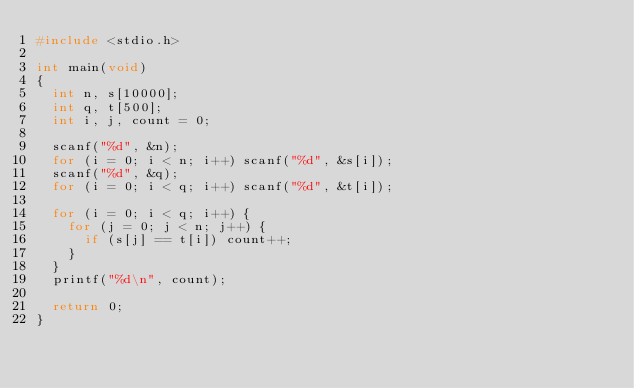Convert code to text. <code><loc_0><loc_0><loc_500><loc_500><_C_>#include <stdio.h>

int main(void)
{
  int n, s[10000];
  int q, t[500];
  int i, j, count = 0;

  scanf("%d", &n);
  for (i = 0; i < n; i++) scanf("%d", &s[i]);
  scanf("%d", &q);
  for (i = 0; i < q; i++) scanf("%d", &t[i]);

  for (i = 0; i < q; i++) {
    for (j = 0; j < n; j++) {
      if (s[j] == t[i]) count++;
    }
  }
  printf("%d\n", count);

  return 0;
}</code> 